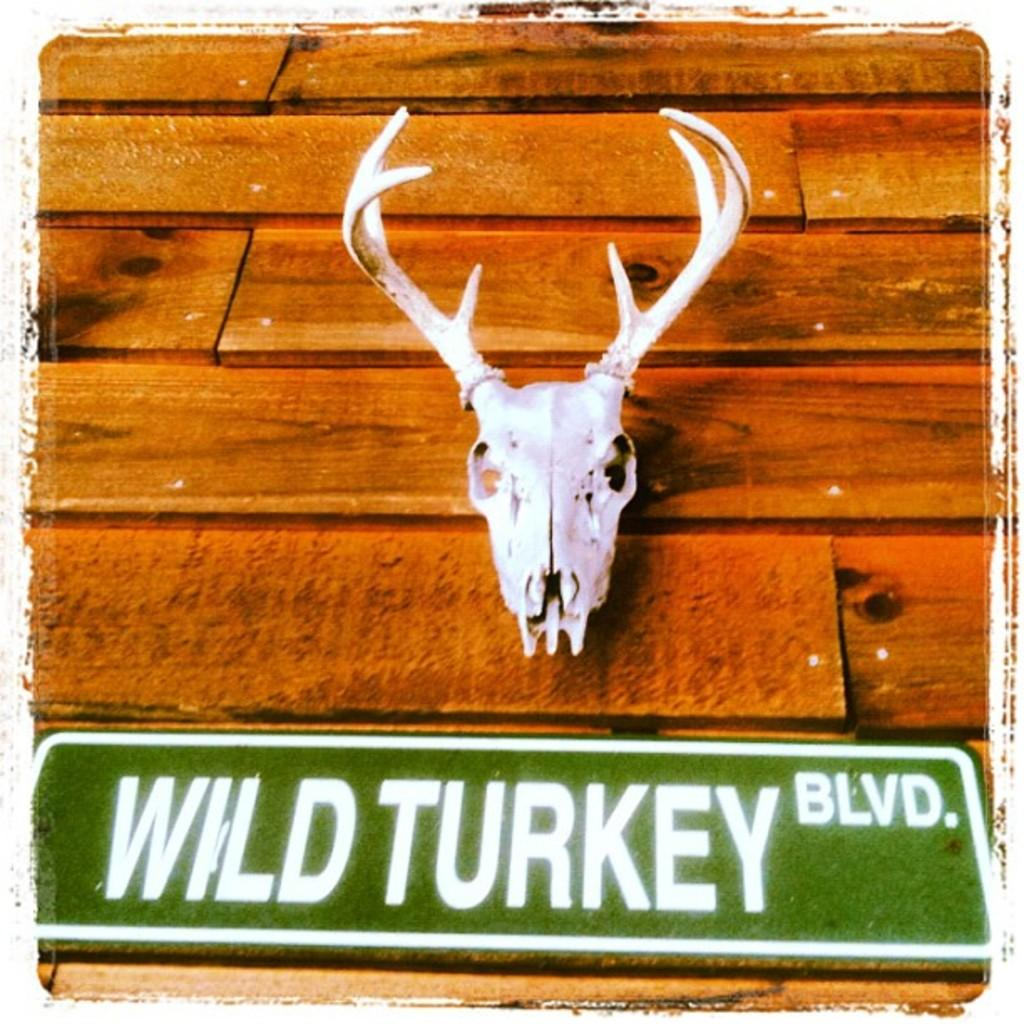What is the main object in the image? There is a name board in the image. What can be found on the name board? The name board has text on it. What is the surface made of that the name board is placed on? The decorative items are placed on a wooden surface. How do we know that the image has been edited? The image is edited, which means it has been altered or modified in some way. Can you see a hill in the background of the image? There is no hill visible in the image; it features a name board with text and decorative items on a wooden surface. Is there a car parked next to the name board in the image? There is no car present in the image; it only shows a name board with text and decorative items on a wooden surface. 